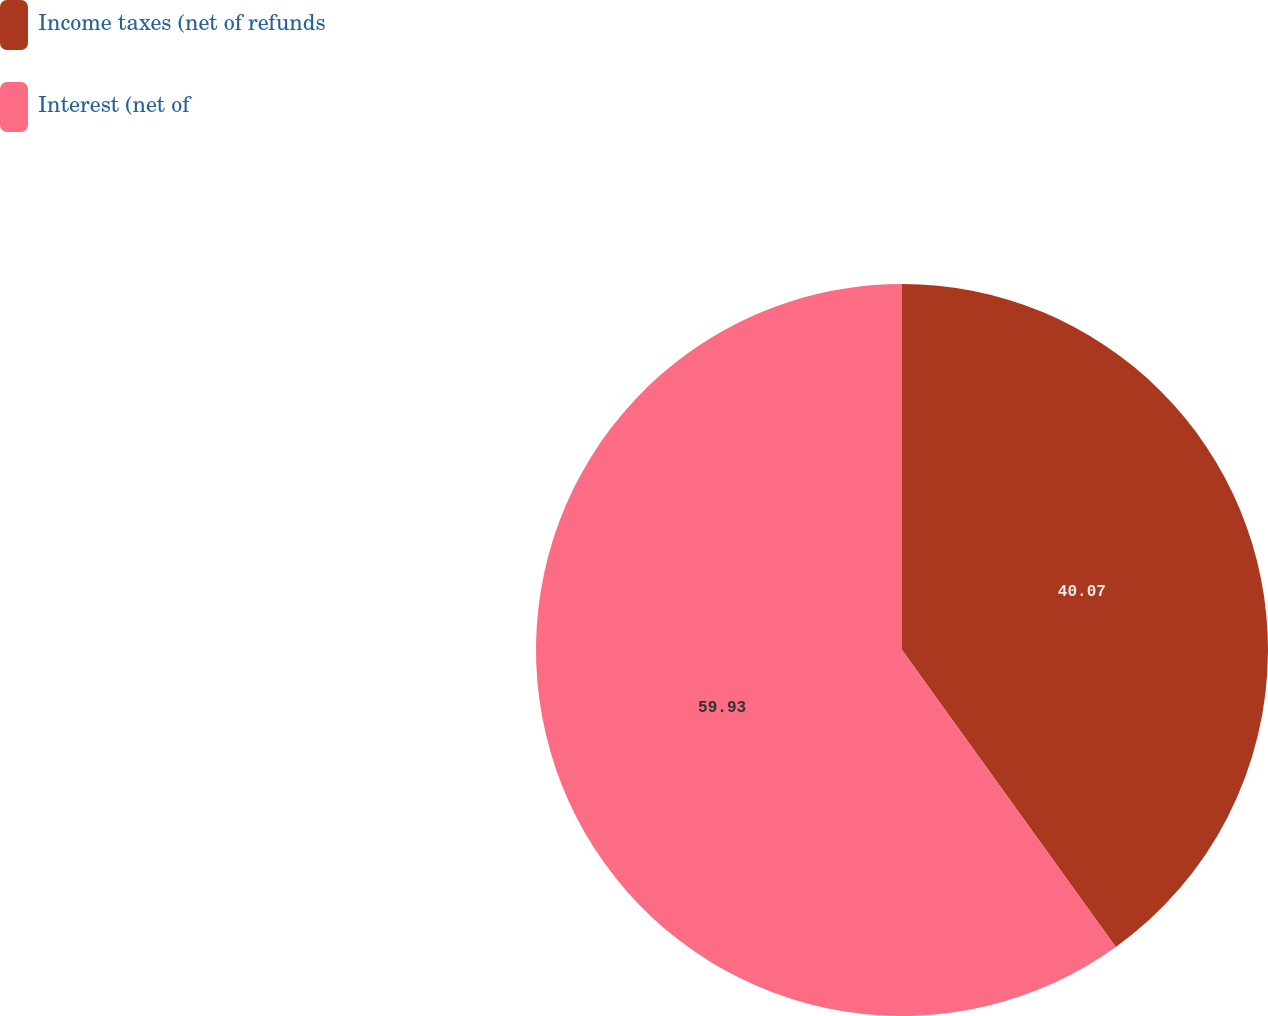Convert chart. <chart><loc_0><loc_0><loc_500><loc_500><pie_chart><fcel>Income taxes (net of refunds<fcel>Interest (net of<nl><fcel>40.07%<fcel>59.93%<nl></chart> 